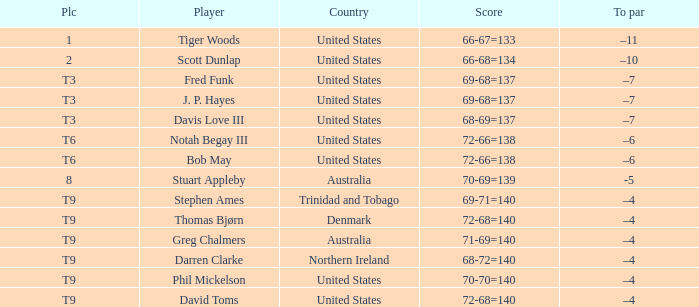What place did Bob May get when his score was 72-66=138? T6. 